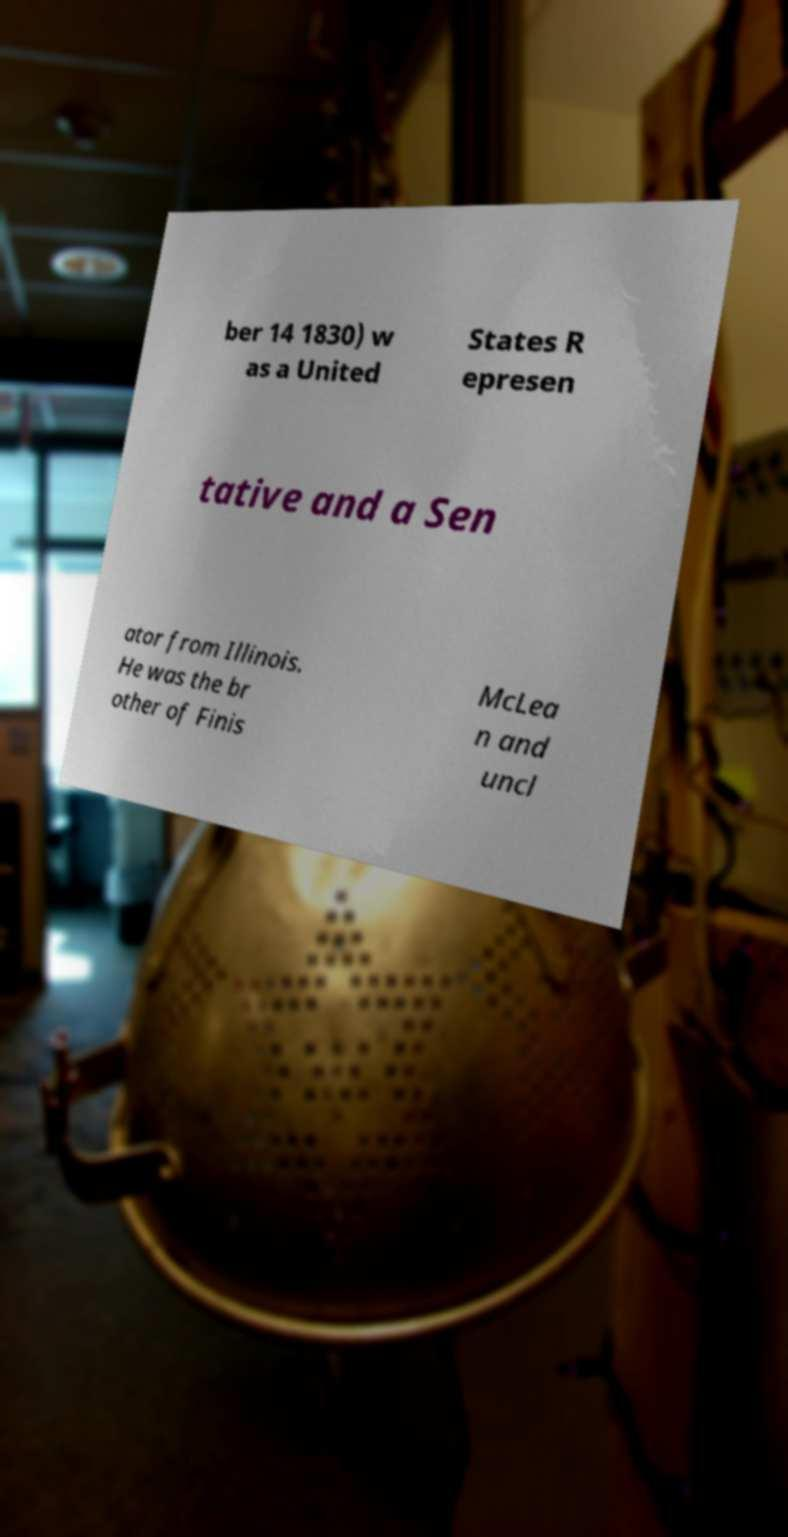Could you extract and type out the text from this image? ber 14 1830) w as a United States R epresen tative and a Sen ator from Illinois. He was the br other of Finis McLea n and uncl 